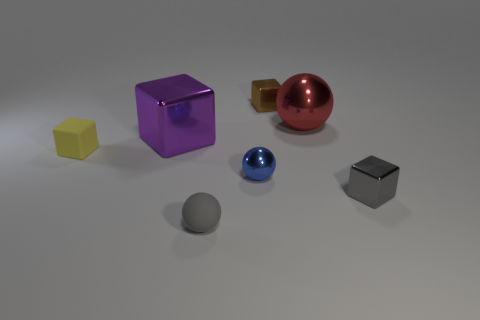Subtract all purple blocks. How many blocks are left? 3 Add 1 tiny yellow shiny cubes. How many objects exist? 8 Subtract all brown cubes. How many cubes are left? 3 Subtract 1 spheres. How many spheres are left? 2 Add 5 tiny gray metal cubes. How many tiny gray metal cubes are left? 6 Add 1 purple metal cubes. How many purple metal cubes exist? 2 Subtract 0 red cylinders. How many objects are left? 7 Subtract all blocks. How many objects are left? 3 Subtract all brown spheres. Subtract all yellow cubes. How many spheres are left? 3 Subtract all tiny brown metallic balls. Subtract all red metallic balls. How many objects are left? 6 